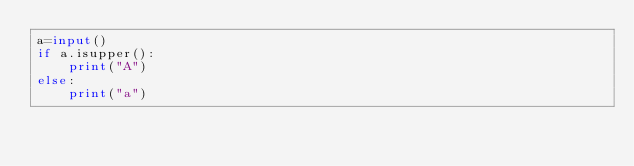Convert code to text. <code><loc_0><loc_0><loc_500><loc_500><_Python_>a=input()
if a.isupper():
    print("A")
else:
    print("a")</code> 